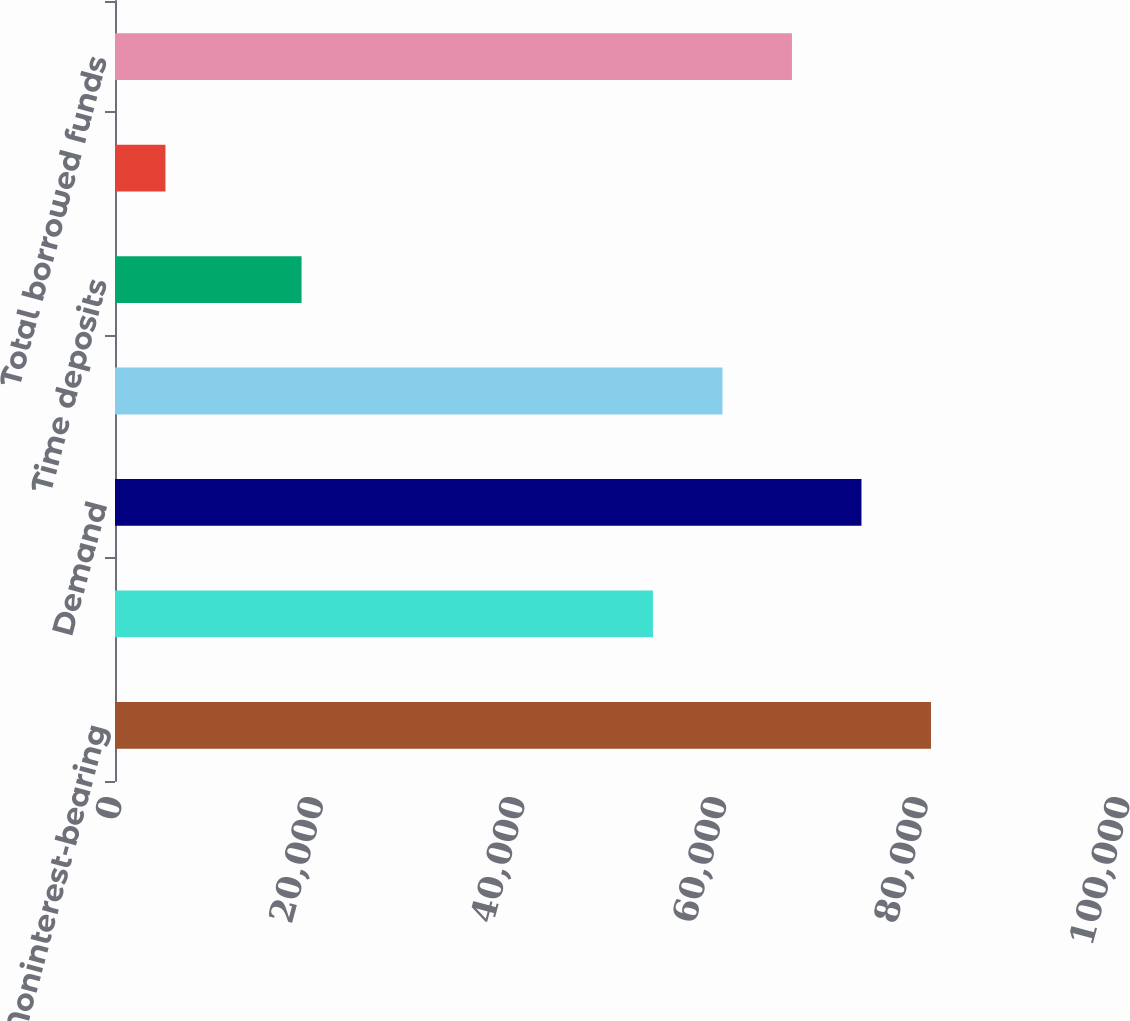Convert chart. <chart><loc_0><loc_0><loc_500><loc_500><bar_chart><fcel>Noninterest-bearing<fcel>Money market<fcel>Demand<fcel>Savings<fcel>Time deposits<fcel>Other<fcel>Total borrowed funds<nl><fcel>80950<fcel>53368<fcel>74054.5<fcel>60263.5<fcel>18507<fcel>5005<fcel>67159<nl></chart> 